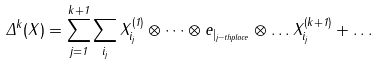Convert formula to latex. <formula><loc_0><loc_0><loc_500><loc_500>\Delta ^ { k } ( X ) = \sum _ { j = 1 } ^ { k + 1 } \sum _ { i _ { j } } X _ { i _ { j } } ^ { ( 1 ) } \otimes \dots \otimes e _ { | _ { j - t h p l a c e } } \otimes \dots X _ { i _ { j } } ^ { ( k + 1 ) } + \dots</formula> 